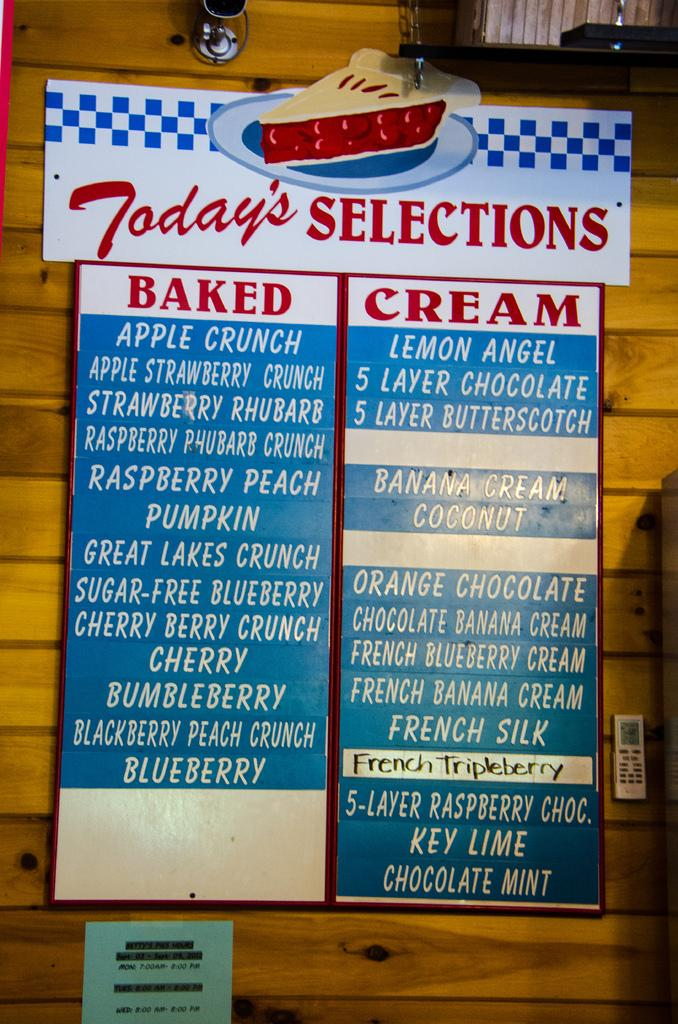<image>
Present a compact description of the photo's key features. A menu of desserts with a sign that says Today's SELECTIONS at the top. 